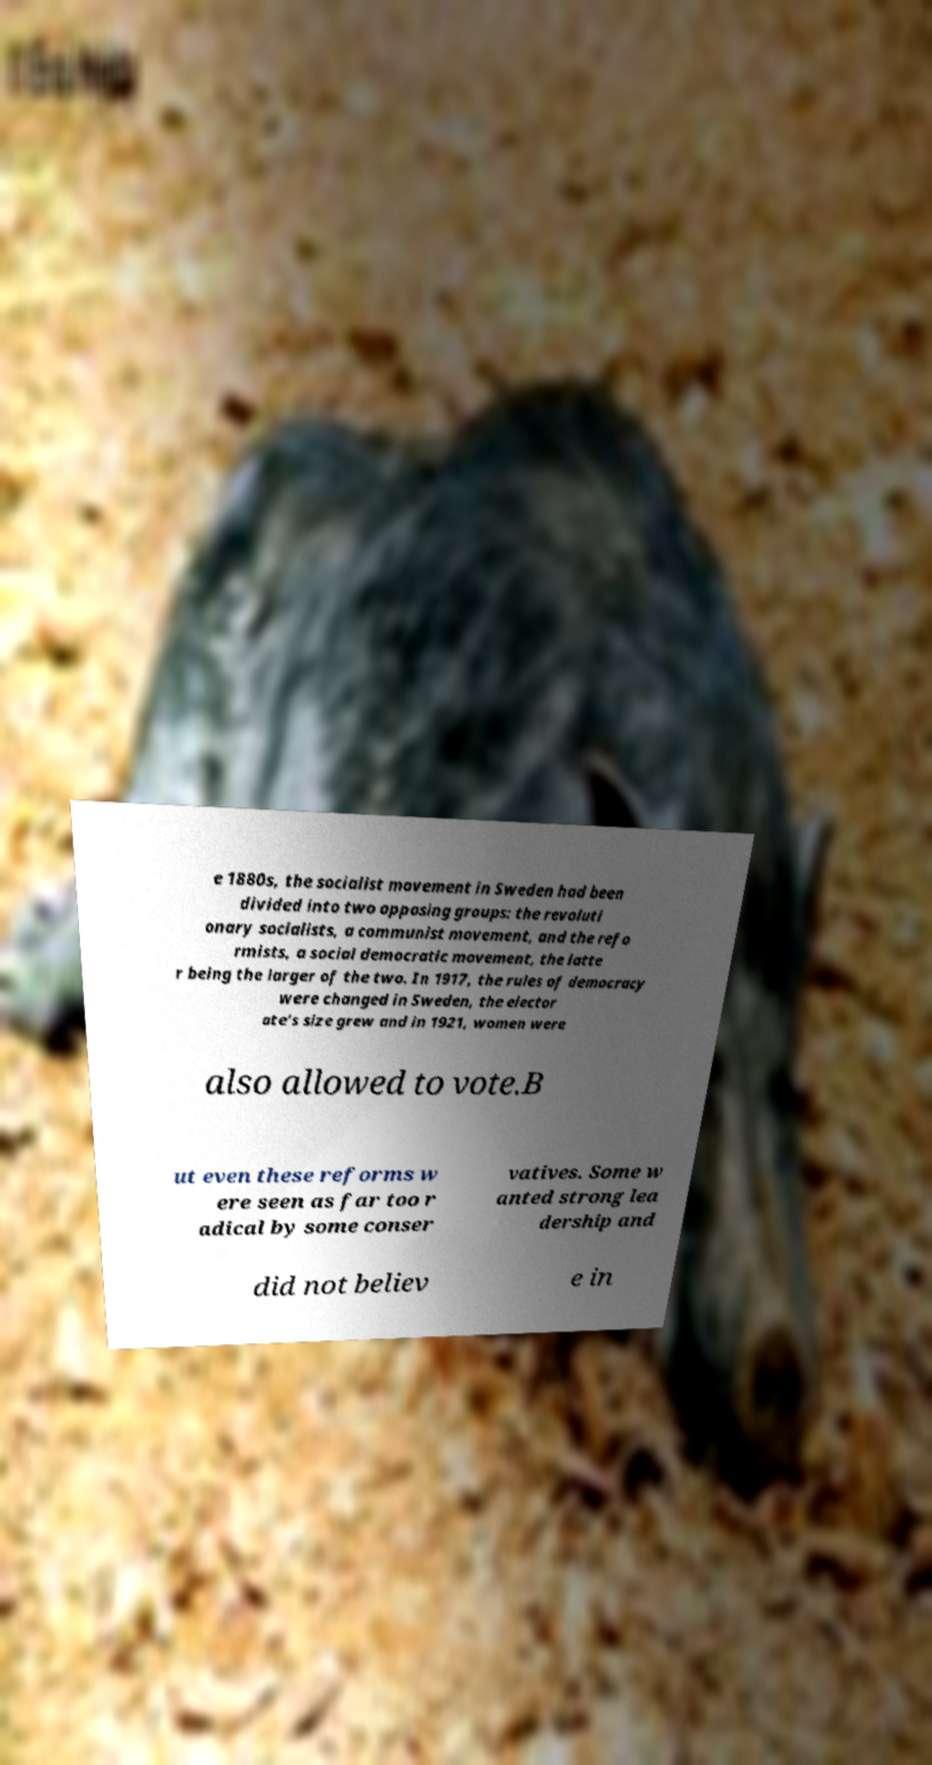There's text embedded in this image that I need extracted. Can you transcribe it verbatim? e 1880s, the socialist movement in Sweden had been divided into two opposing groups: the revoluti onary socialists, a communist movement, and the refo rmists, a social democratic movement, the latte r being the larger of the two. In 1917, the rules of democracy were changed in Sweden, the elector ate’s size grew and in 1921, women were also allowed to vote.B ut even these reforms w ere seen as far too r adical by some conser vatives. Some w anted strong lea dership and did not believ e in 